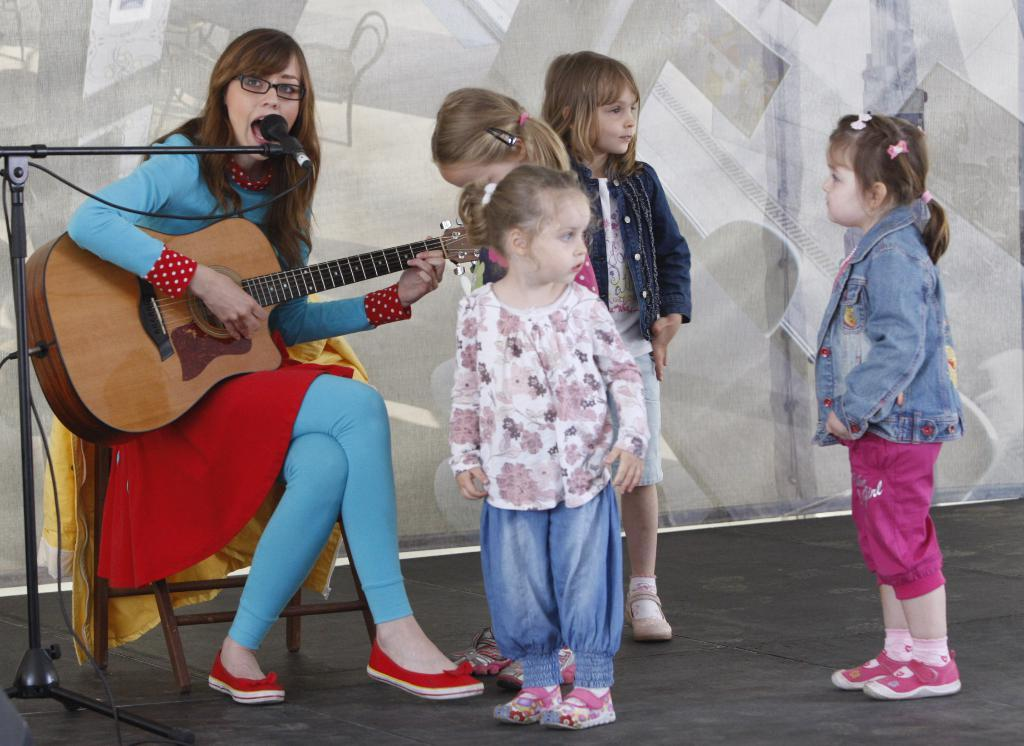Who is the main subject in the image? There is a woman in the image. What is the woman doing in the image? The woman is sitting on a chair and holding a guitar. What other objects are present in the image? There is a microphone in the image. How many girls are in the image? There are four girls in the image. What are the girls doing in the image? The girls are standing. What type of pet is sitting on the woman's lap in the image? There is no pet present in the image; the woman is holding a guitar. 